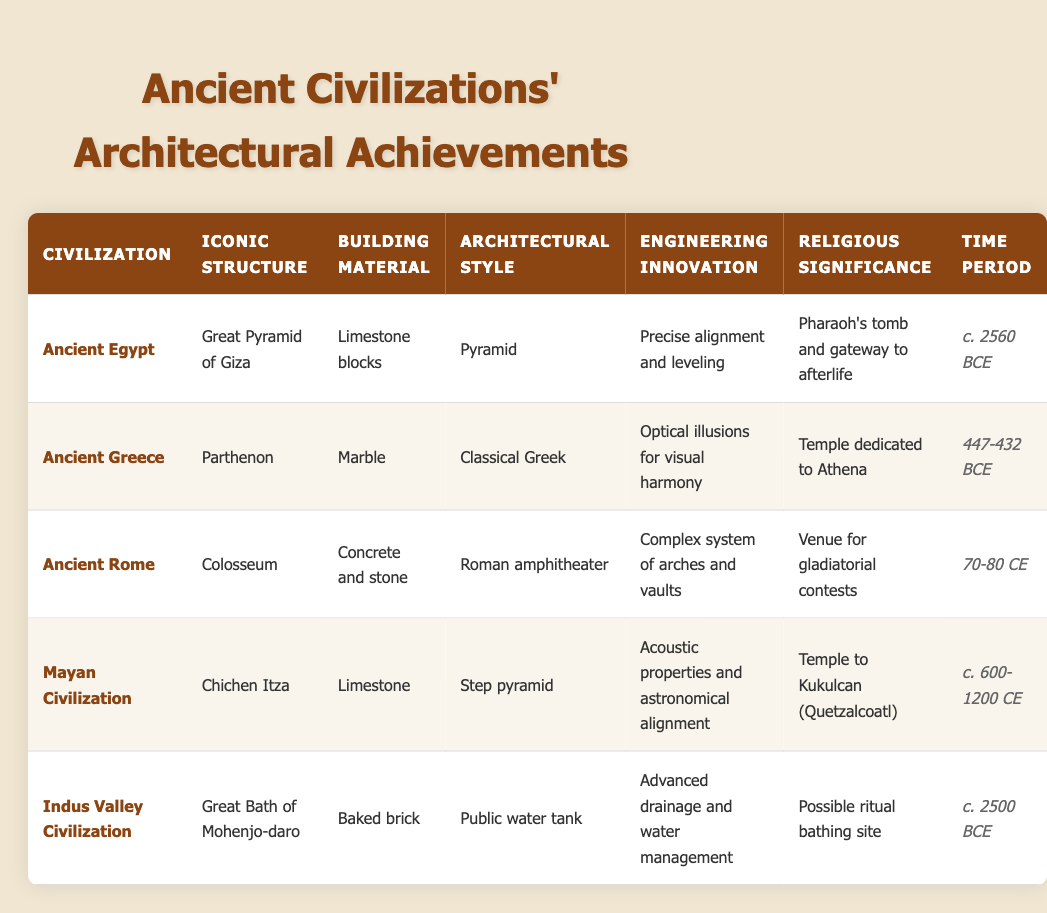What is the iconic structure of Ancient Egypt? The specific row for Ancient Egypt lists the iconic structure as the Great Pyramid of Giza.
Answer: Great Pyramid of Giza What building material was used in the construction of the Colosseum? In the row for Ancient Rome, the building material specified for the Colosseum is concrete and stone.
Answer: Concrete and stone Which civilization has an engineering innovation related to acoustic properties and astronomical alignment? Referring to the data for Mayan Civilization, the entry indicates that their innovation involved acoustic properties and astronomical alignment in the construction of their structures.
Answer: Mayan Civilization True or False: The Great Bath of Mohenjo-daro is a temple dedicated to a deity. The data describes the Great Bath of Mohenjo-daro as a possible ritual bathing site, not a temple dedicated to a deity, making this statement false.
Answer: False What architectural style is associated with the Parthenon? Looking at the row for Ancient Greece, the architectural style associated with the Parthenon is classified as Classical Greek.
Answer: Classical Greek Which civilization's iconic structure is the step pyramid? In the table for the Mayan Civilization, the iconic structure is mentioned as Chichen Itza, which is a step pyramid.
Answer: Mayan Civilization What is the time period for the construction of the Great Pyramid of Giza, and how does it compare to that of the Colosseum? The Great Pyramid of Giza was constructed around c. 2560 BCE, while the Colosseum was constructed between 70-80 CE. To compare these, the Great Pyramid was built about 2630 years earlier than the Colosseum.
Answer: c. 2560 BCE; 2630 years earlier Which civilization's architectural achievements include a temple dedicated to Athena? The relevant row shows that the Parthenon, which is an iconic structure of Ancient Greece, is a temple dedicated to Athena.
Answer: Ancient Greece What was the main religious significance of the Colosseum? The table describes the religious significance of the Colosseum as being a venue for gladiatorial contests, indicating it served a more public entertainment role rather than a strict religious one.
Answer: Venue for gladiatorial contests 